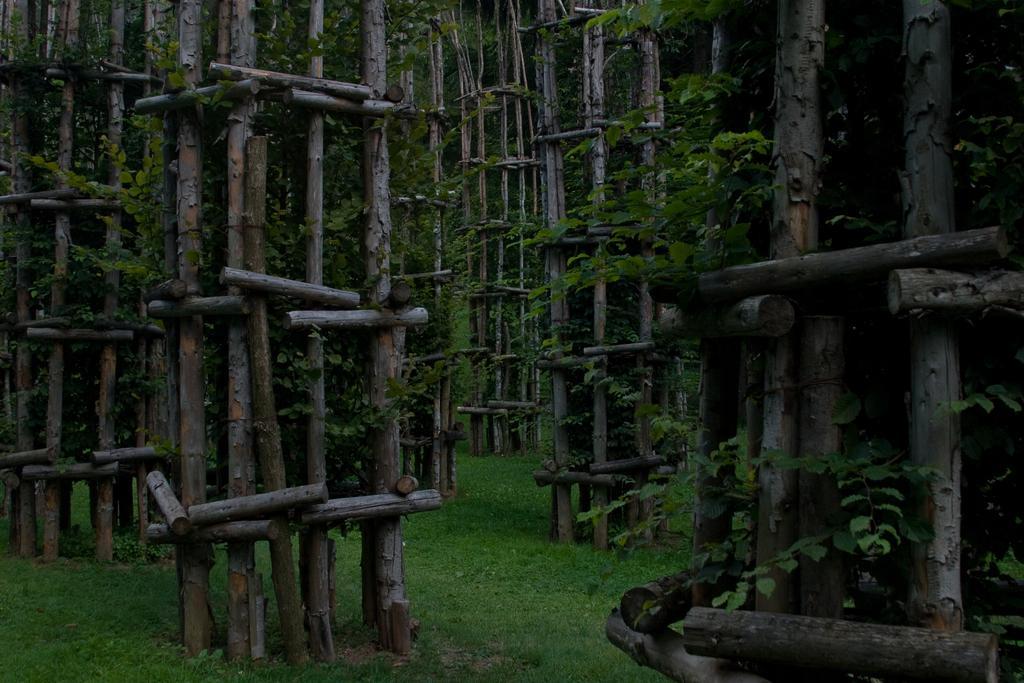How would you summarize this image in a sentence or two? There are many bamboos in the image. There are creepers. At the bottom of the image there is grass. 